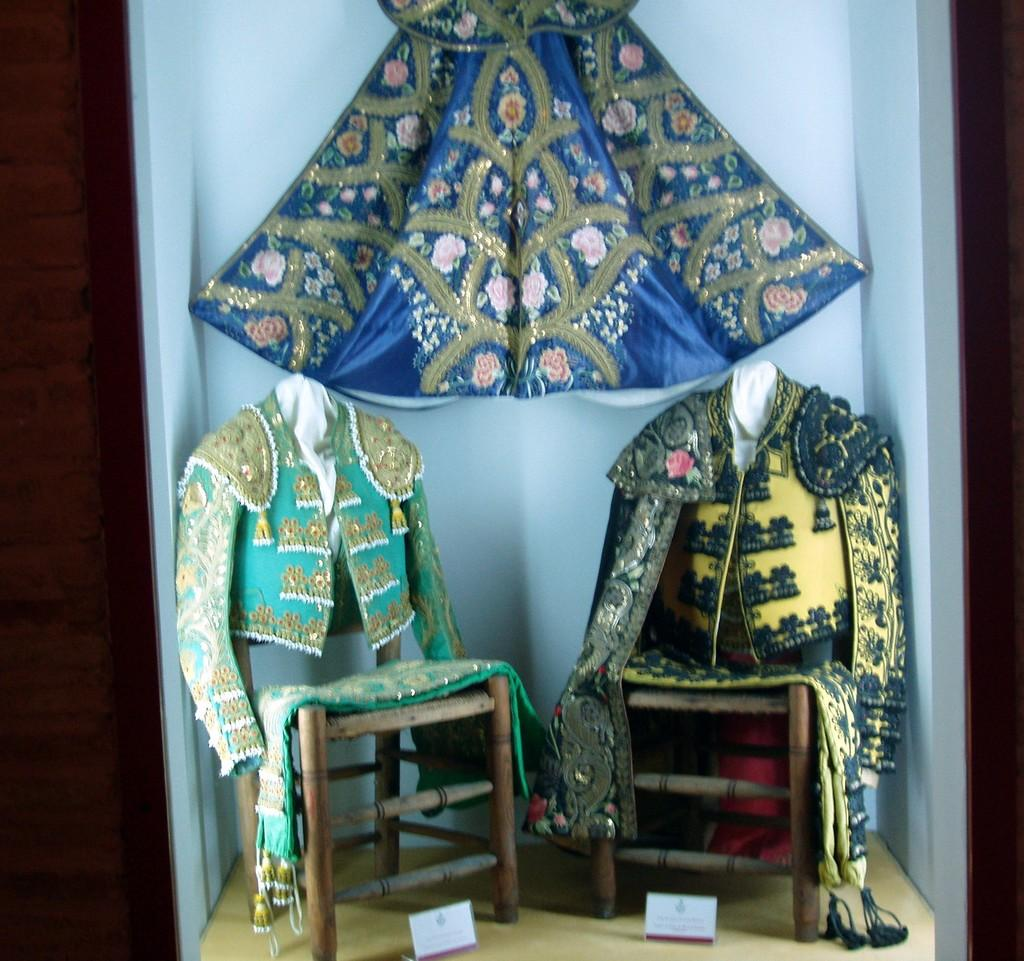What items are placed on the chairs in the image? There are jackets on chairs in the image. What is placed in front of the chairs? There are name boards in front of the chairs. What can be seen on the wall in the background of the image? There is cloth on the wall in the background of the image. Can you hear the stranger talking in the image? There is no stranger or any indication of sound in the image. What type of sponge is used to clean the cloth on the wall? There is no sponge present in the image, and the purpose of the cloth on the wall is not specified. 